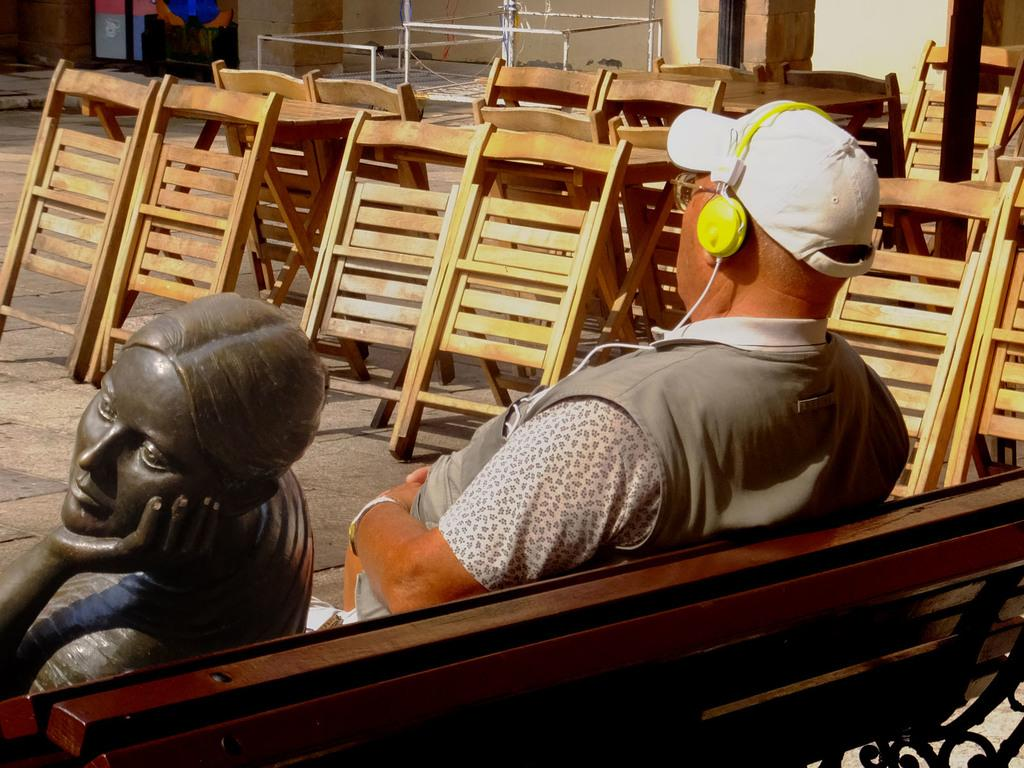Who is present in the image? There is a man in the image. What is the man doing in the image? The man is sitting on a bench. What is the man wearing on his ears? The man is wearing headphones. What type of hat is the man wearing? The man is wearing a white-colored cap. Can you see a tree in the image? There is no tree present in the image. What type of stamp is the man holding in the image? There is no stamp present in the image. 